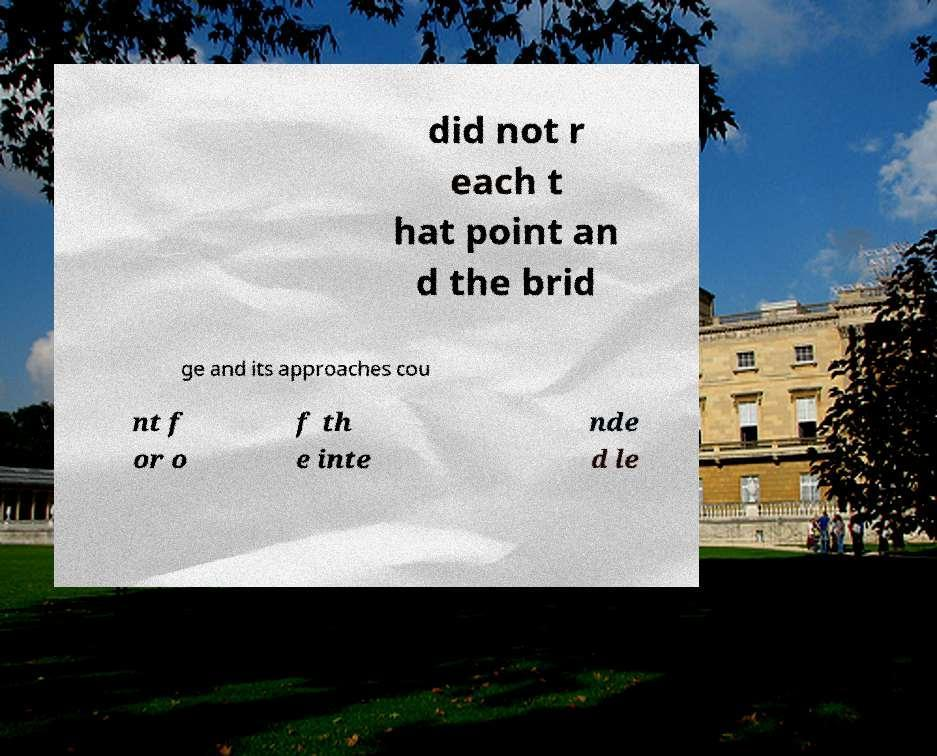Can you read and provide the text displayed in the image?This photo seems to have some interesting text. Can you extract and type it out for me? did not r each t hat point an d the brid ge and its approaches cou nt f or o f th e inte nde d le 